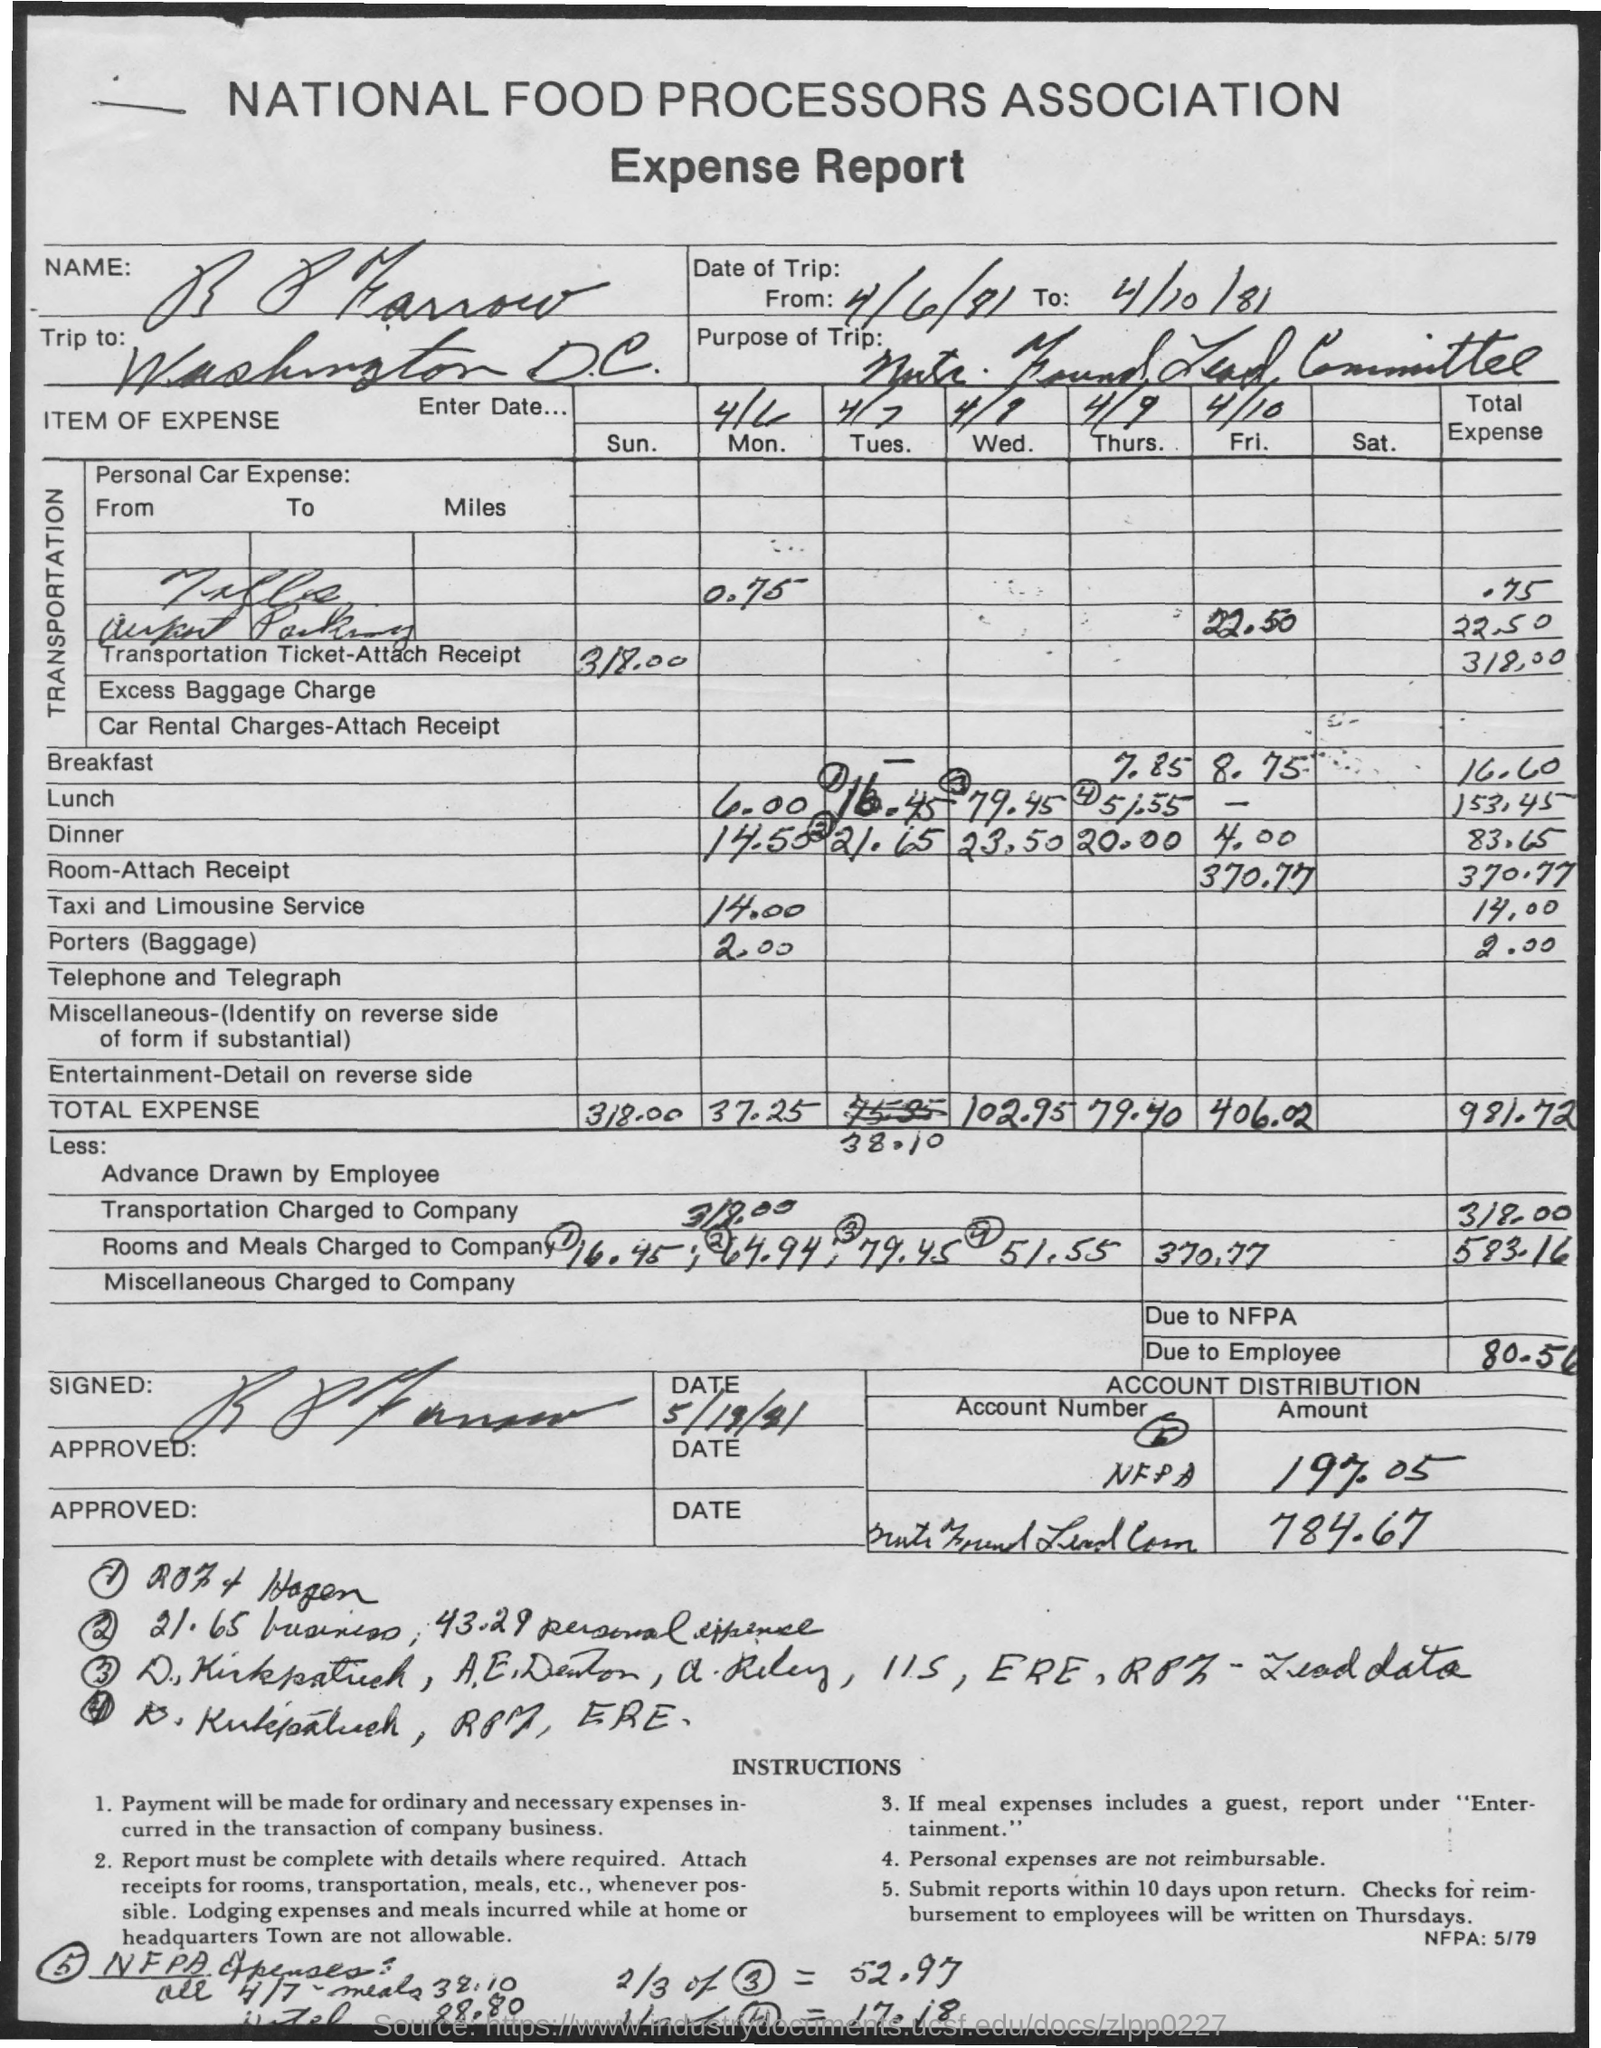Was there any advance drawn by the employee, and how does it affect the total due? Yes, an advance of $318.00 was drawn by the employee, which is factored into the overall calculations on the expense report. This advance reduces the total amount due to the employee after all other expenses are accounted for. 